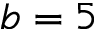Convert formula to latex. <formula><loc_0><loc_0><loc_500><loc_500>b = 5</formula> 